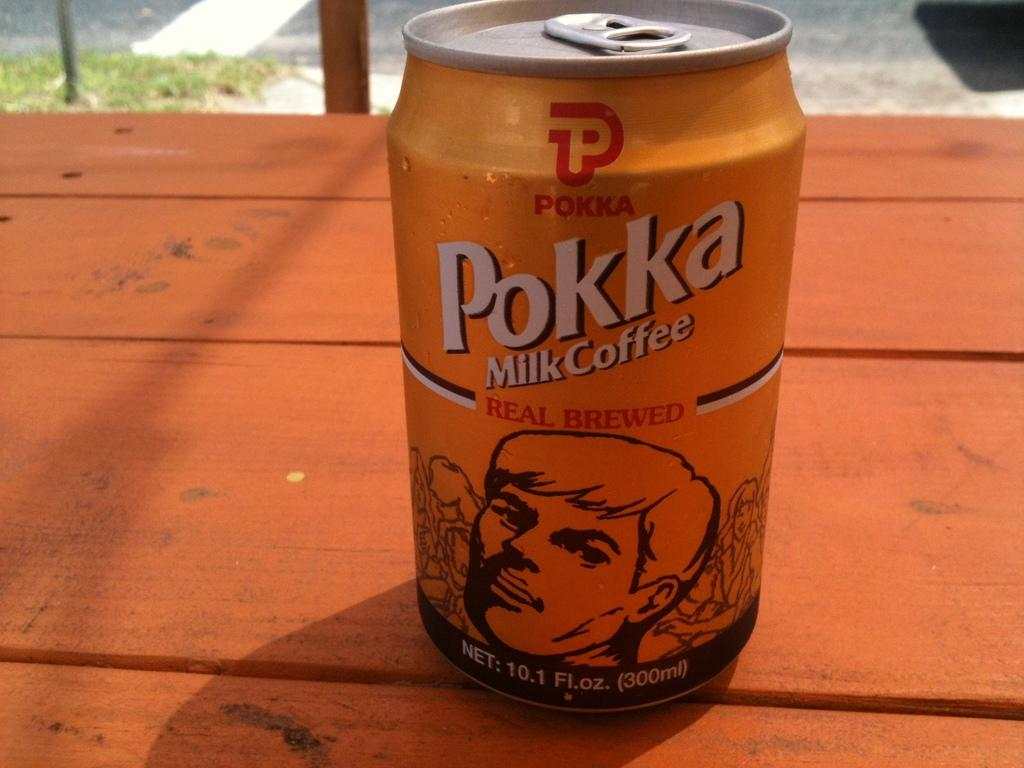Provide a one-sentence caption for the provided image. Orange can of beer that reads Pokka on a wooden table. 